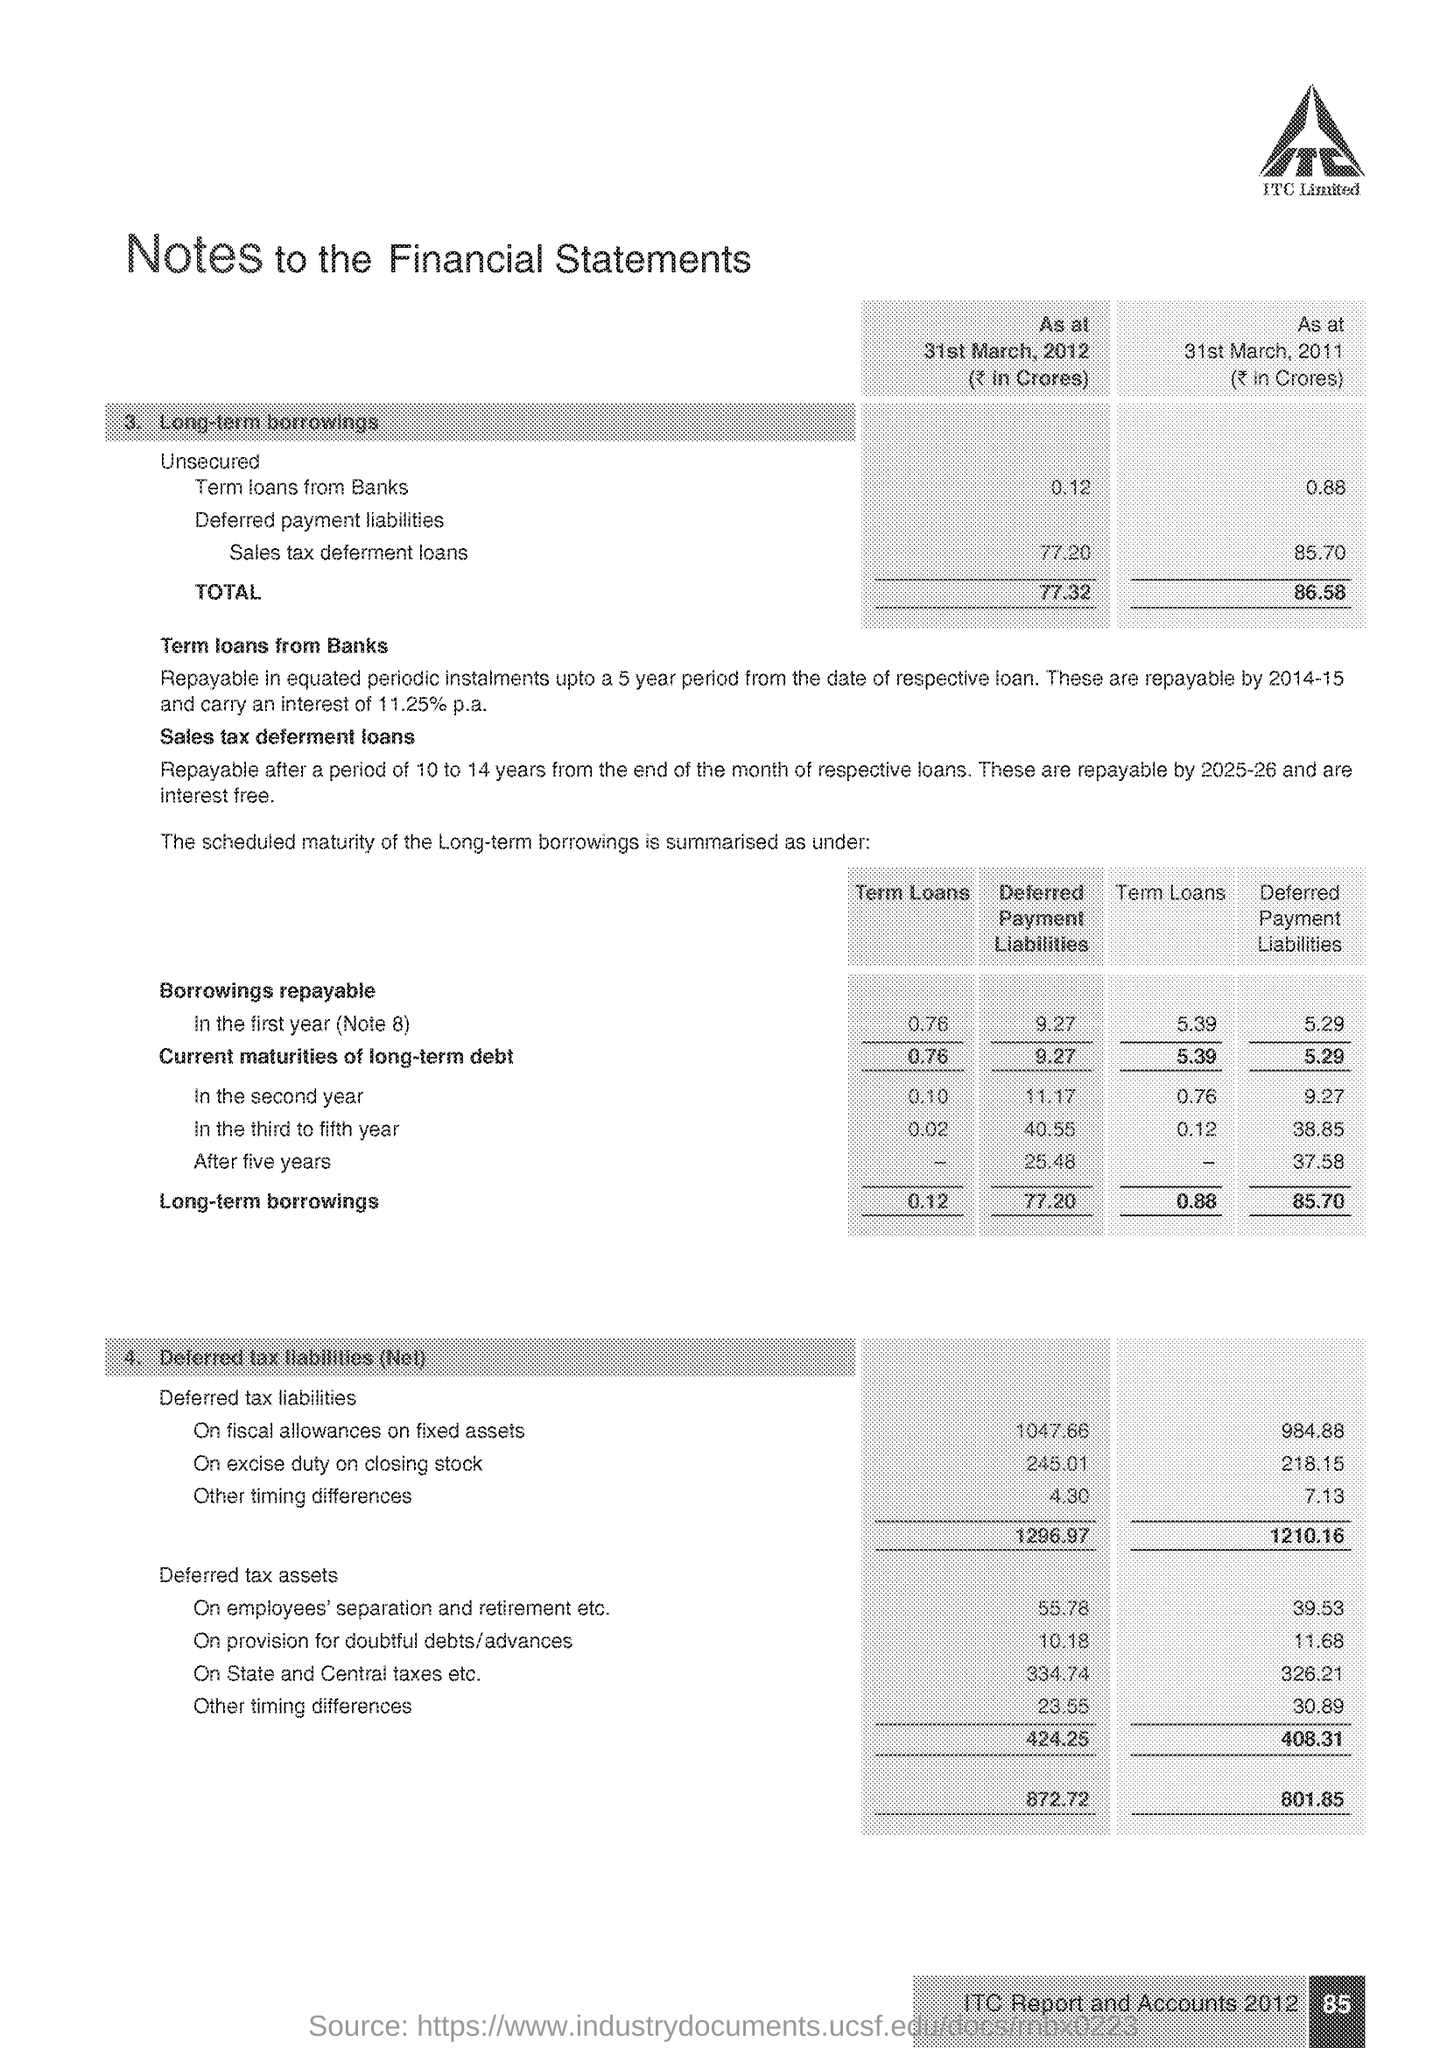What is long term borrowings total of term loan as per 31st March 2012?
Make the answer very short. 0.12. What is total of long term borrowings as per 31st March 2011?
Ensure brevity in your answer.  86.58. 